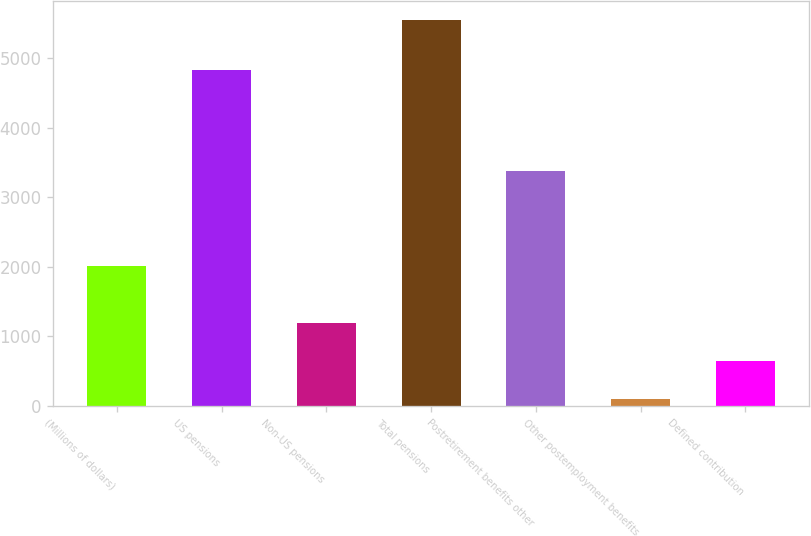<chart> <loc_0><loc_0><loc_500><loc_500><bar_chart><fcel>(Millions of dollars)<fcel>US pensions<fcel>Non-US pensions<fcel>Total pensions<fcel>Postretirement benefits other<fcel>Other postemployment benefits<fcel>Defined contribution<nl><fcel>2016<fcel>4833<fcel>1194.8<fcel>5550<fcel>3376<fcel>106<fcel>650.4<nl></chart> 